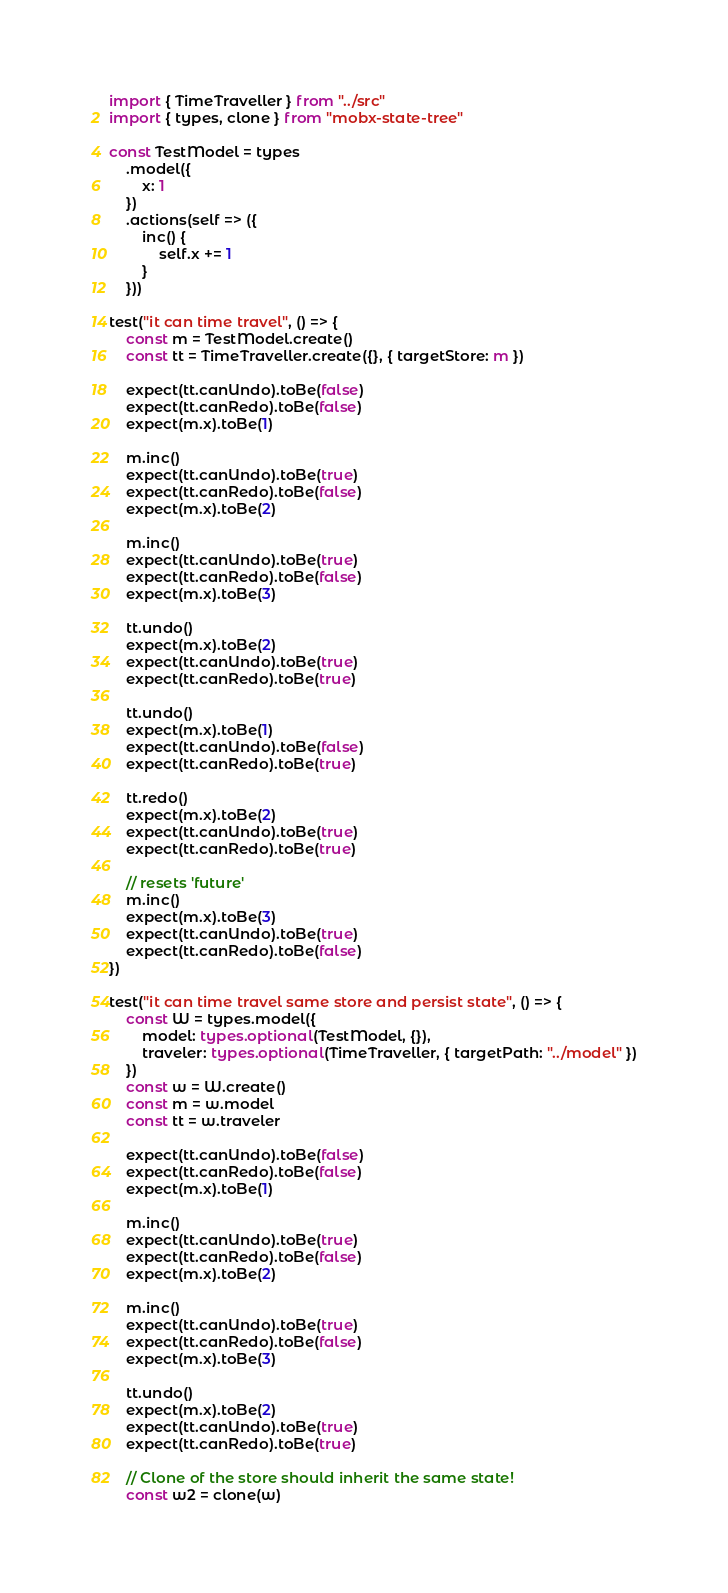<code> <loc_0><loc_0><loc_500><loc_500><_TypeScript_>import { TimeTraveller } from "../src"
import { types, clone } from "mobx-state-tree"

const TestModel = types
    .model({
        x: 1
    })
    .actions(self => ({
        inc() {
            self.x += 1
        }
    }))

test("it can time travel", () => {
    const m = TestModel.create()
    const tt = TimeTraveller.create({}, { targetStore: m })

    expect(tt.canUndo).toBe(false)
    expect(tt.canRedo).toBe(false)
    expect(m.x).toBe(1)

    m.inc()
    expect(tt.canUndo).toBe(true)
    expect(tt.canRedo).toBe(false)
    expect(m.x).toBe(2)

    m.inc()
    expect(tt.canUndo).toBe(true)
    expect(tt.canRedo).toBe(false)
    expect(m.x).toBe(3)

    tt.undo()
    expect(m.x).toBe(2)
    expect(tt.canUndo).toBe(true)
    expect(tt.canRedo).toBe(true)

    tt.undo()
    expect(m.x).toBe(1)
    expect(tt.canUndo).toBe(false)
    expect(tt.canRedo).toBe(true)

    tt.redo()
    expect(m.x).toBe(2)
    expect(tt.canUndo).toBe(true)
    expect(tt.canRedo).toBe(true)

    // resets 'future'
    m.inc()
    expect(m.x).toBe(3)
    expect(tt.canUndo).toBe(true)
    expect(tt.canRedo).toBe(false)
})

test("it can time travel same store and persist state", () => {
    const W = types.model({
        model: types.optional(TestModel, {}),
        traveler: types.optional(TimeTraveller, { targetPath: "../model" })
    })
    const w = W.create()
    const m = w.model
    const tt = w.traveler

    expect(tt.canUndo).toBe(false)
    expect(tt.canRedo).toBe(false)
    expect(m.x).toBe(1)

    m.inc()
    expect(tt.canUndo).toBe(true)
    expect(tt.canRedo).toBe(false)
    expect(m.x).toBe(2)

    m.inc()
    expect(tt.canUndo).toBe(true)
    expect(tt.canRedo).toBe(false)
    expect(m.x).toBe(3)

    tt.undo()
    expect(m.x).toBe(2)
    expect(tt.canUndo).toBe(true)
    expect(tt.canRedo).toBe(true)

    // Clone of the store should inherit the same state!
    const w2 = clone(w)</code> 